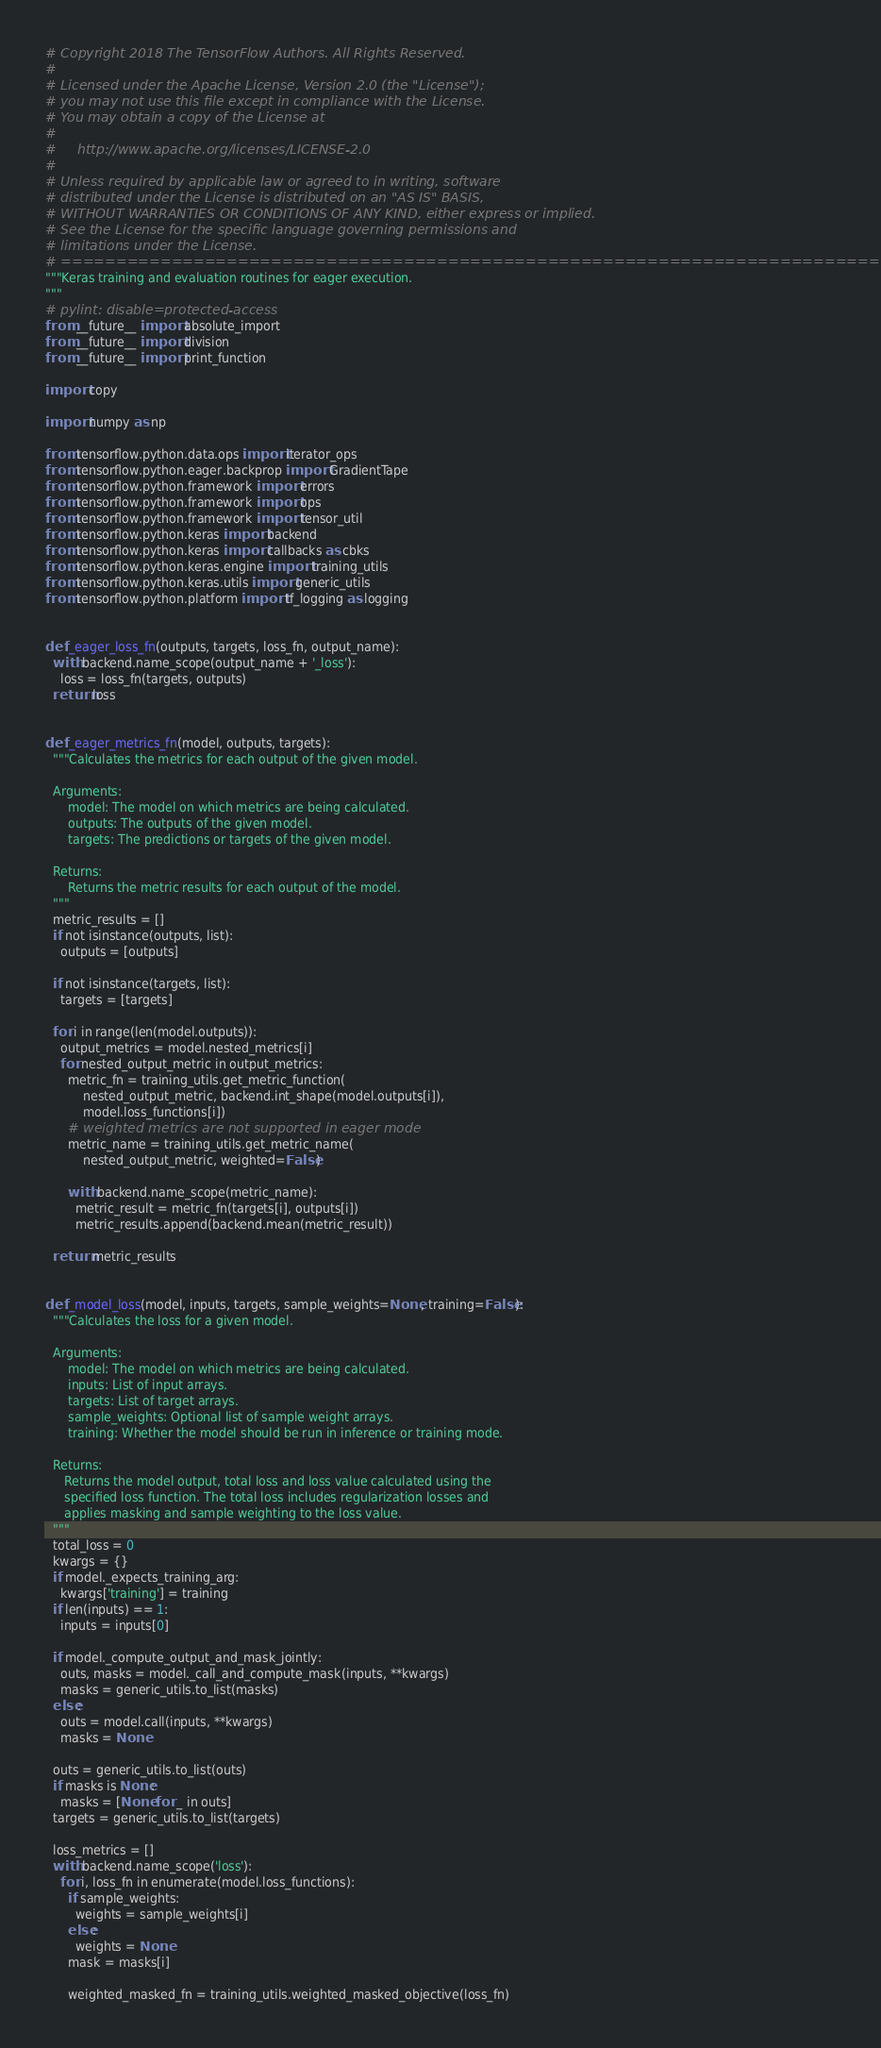<code> <loc_0><loc_0><loc_500><loc_500><_Python_># Copyright 2018 The TensorFlow Authors. All Rights Reserved.
#
# Licensed under the Apache License, Version 2.0 (the "License");
# you may not use this file except in compliance with the License.
# You may obtain a copy of the License at
#
#     http://www.apache.org/licenses/LICENSE-2.0
#
# Unless required by applicable law or agreed to in writing, software
# distributed under the License is distributed on an "AS IS" BASIS,
# WITHOUT WARRANTIES OR CONDITIONS OF ANY KIND, either express or implied.
# See the License for the specific language governing permissions and
# limitations under the License.
# ==============================================================================
"""Keras training and evaluation routines for eager execution.
"""
# pylint: disable=protected-access
from __future__ import absolute_import
from __future__ import division
from __future__ import print_function

import copy

import numpy as np

from tensorflow.python.data.ops import iterator_ops
from tensorflow.python.eager.backprop import GradientTape
from tensorflow.python.framework import errors
from tensorflow.python.framework import ops
from tensorflow.python.framework import tensor_util
from tensorflow.python.keras import backend
from tensorflow.python.keras import callbacks as cbks
from tensorflow.python.keras.engine import training_utils
from tensorflow.python.keras.utils import generic_utils
from tensorflow.python.platform import tf_logging as logging


def _eager_loss_fn(outputs, targets, loss_fn, output_name):
  with backend.name_scope(output_name + '_loss'):
    loss = loss_fn(targets, outputs)
  return loss


def _eager_metrics_fn(model, outputs, targets):
  """Calculates the metrics for each output of the given model.

  Arguments:
      model: The model on which metrics are being calculated.
      outputs: The outputs of the given model.
      targets: The predictions or targets of the given model.

  Returns:
      Returns the metric results for each output of the model.
  """
  metric_results = []
  if not isinstance(outputs, list):
    outputs = [outputs]

  if not isinstance(targets, list):
    targets = [targets]

  for i in range(len(model.outputs)):
    output_metrics = model.nested_metrics[i]
    for nested_output_metric in output_metrics:
      metric_fn = training_utils.get_metric_function(
          nested_output_metric, backend.int_shape(model.outputs[i]),
          model.loss_functions[i])
      # weighted metrics are not supported in eager mode
      metric_name = training_utils.get_metric_name(
          nested_output_metric, weighted=False)

      with backend.name_scope(metric_name):
        metric_result = metric_fn(targets[i], outputs[i])
        metric_results.append(backend.mean(metric_result))

  return metric_results


def _model_loss(model, inputs, targets, sample_weights=None, training=False):
  """Calculates the loss for a given model.

  Arguments:
      model: The model on which metrics are being calculated.
      inputs: List of input arrays.
      targets: List of target arrays.
      sample_weights: Optional list of sample weight arrays.
      training: Whether the model should be run in inference or training mode.

  Returns:
     Returns the model output, total loss and loss value calculated using the
     specified loss function. The total loss includes regularization losses and
     applies masking and sample weighting to the loss value.
  """
  total_loss = 0
  kwargs = {}
  if model._expects_training_arg:
    kwargs['training'] = training
  if len(inputs) == 1:
    inputs = inputs[0]

  if model._compute_output_and_mask_jointly:
    outs, masks = model._call_and_compute_mask(inputs, **kwargs)
    masks = generic_utils.to_list(masks)
  else:
    outs = model.call(inputs, **kwargs)
    masks = None

  outs = generic_utils.to_list(outs)
  if masks is None:
    masks = [None for _ in outs]
  targets = generic_utils.to_list(targets)

  loss_metrics = []
  with backend.name_scope('loss'):
    for i, loss_fn in enumerate(model.loss_functions):
      if sample_weights:
        weights = sample_weights[i]
      else:
        weights = None
      mask = masks[i]

      weighted_masked_fn = training_utils.weighted_masked_objective(loss_fn)</code> 